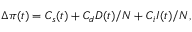Convert formula to latex. <formula><loc_0><loc_0><loc_500><loc_500>\begin{array} { r } { \Delta \pi ( t ) = C _ { s } ( t ) + { C } _ { d } D ( t ) / N + { C } _ { i } I ( t ) / N , } \end{array}</formula> 